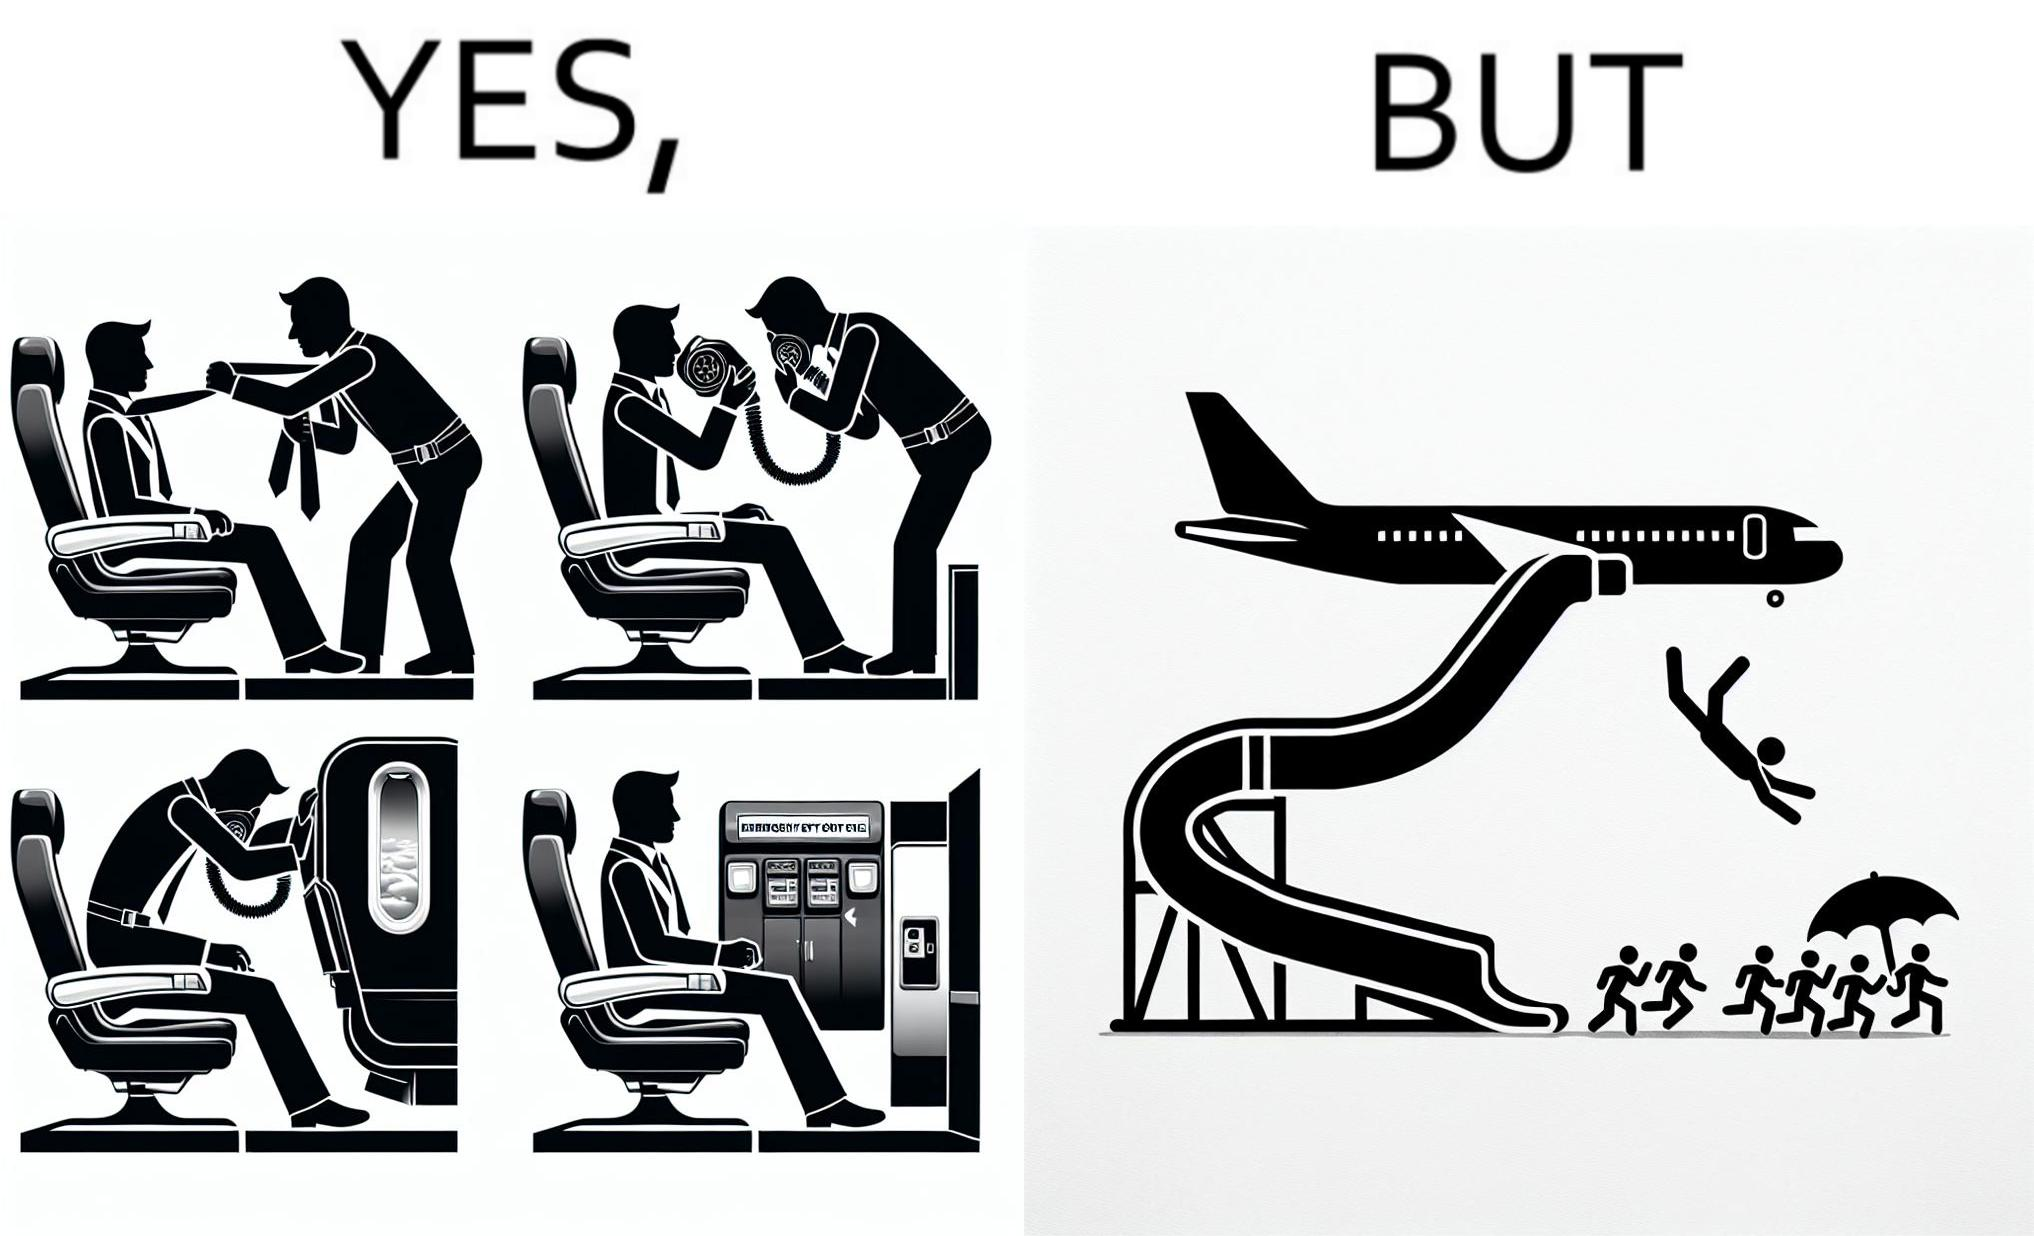What is shown in the left half versus the right half of this image? In the left part of the image: They are images of what one should do in an airplane in case of an imminent collision and fire In the right part of the image: It shows a man jumping out of an airplane in case of an emergency and using the emergency inflatable slides 